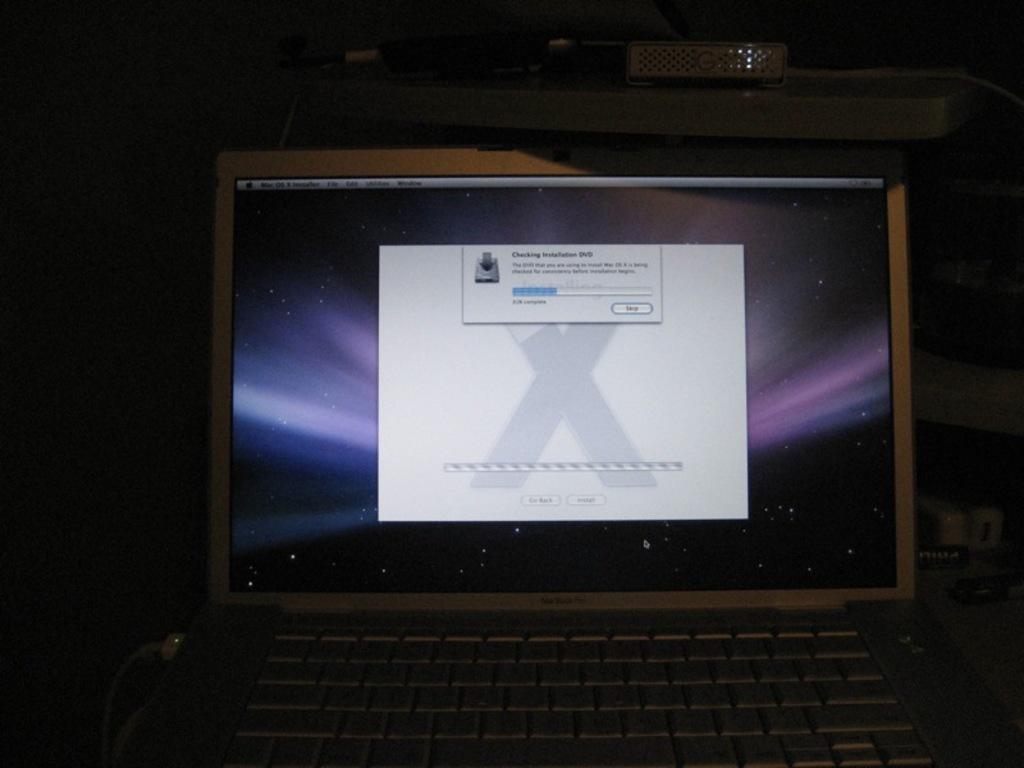Laptop displayed some errors?
Keep it short and to the point. Unanswerable. 